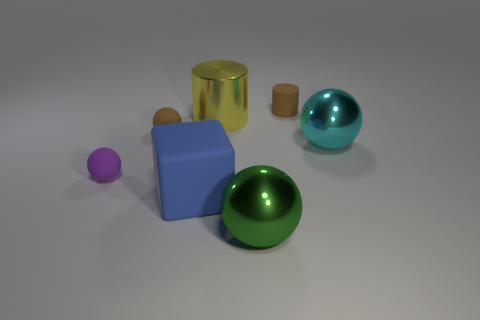Subtract 1 balls. How many balls are left? 3 Subtract all green spheres. How many spheres are left? 3 Subtract all red balls. Subtract all red cylinders. How many balls are left? 4 Add 1 big blue rubber cubes. How many objects exist? 8 Subtract all balls. How many objects are left? 3 Add 3 large balls. How many large balls are left? 5 Add 2 blue metal balls. How many blue metal balls exist? 2 Subtract 1 purple spheres. How many objects are left? 6 Subtract all big cyan shiny balls. Subtract all cyan metallic balls. How many objects are left? 5 